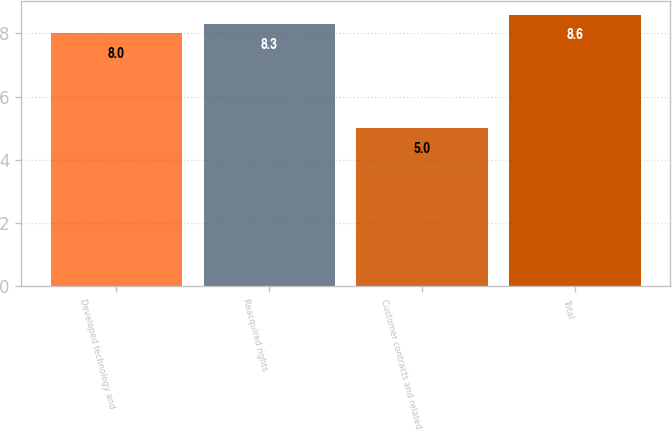Convert chart to OTSL. <chart><loc_0><loc_0><loc_500><loc_500><bar_chart><fcel>Developed technology and<fcel>Reacquired rights<fcel>Customer contracts and related<fcel>Total<nl><fcel>8<fcel>8.3<fcel>5<fcel>8.6<nl></chart> 